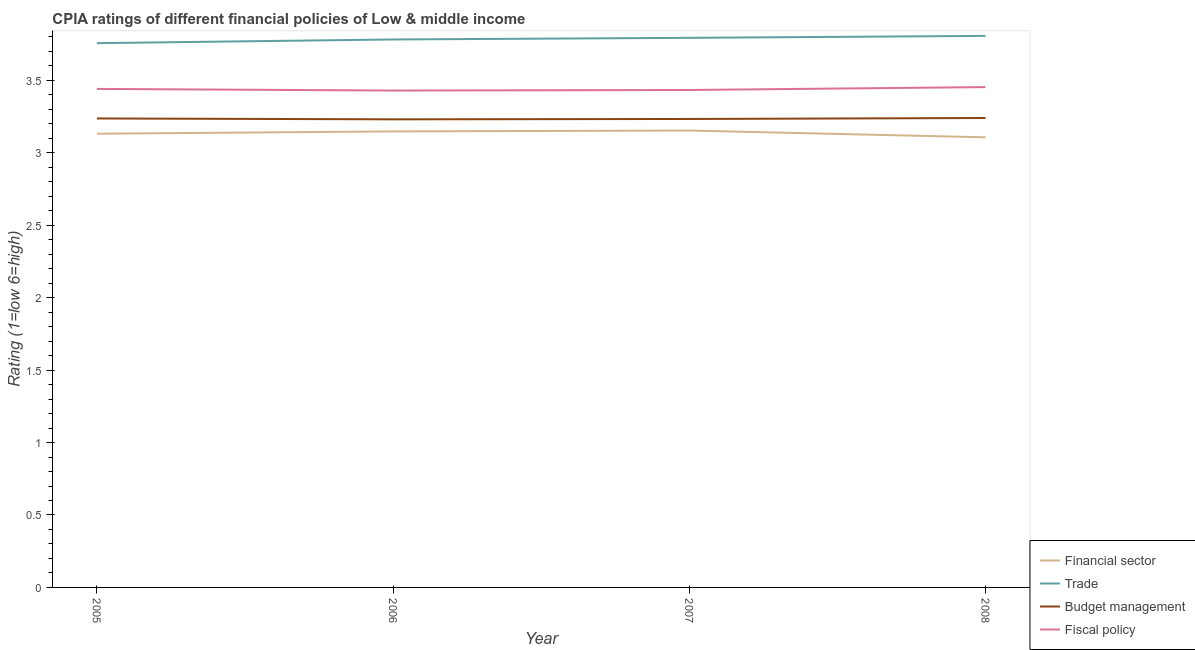How many different coloured lines are there?
Ensure brevity in your answer.  4. Does the line corresponding to cpia rating of financial sector intersect with the line corresponding to cpia rating of budget management?
Ensure brevity in your answer.  No. What is the cpia rating of financial sector in 2005?
Provide a succinct answer. 3.13. Across all years, what is the maximum cpia rating of fiscal policy?
Your answer should be compact. 3.45. Across all years, what is the minimum cpia rating of budget management?
Ensure brevity in your answer.  3.23. In which year was the cpia rating of trade maximum?
Your answer should be very brief. 2008. What is the total cpia rating of trade in the graph?
Keep it short and to the point. 15.14. What is the difference between the cpia rating of budget management in 2007 and that in 2008?
Your response must be concise. -0.01. What is the difference between the cpia rating of trade in 2007 and the cpia rating of financial sector in 2008?
Offer a terse response. 0.69. What is the average cpia rating of budget management per year?
Offer a very short reply. 3.24. In the year 2007, what is the difference between the cpia rating of fiscal policy and cpia rating of trade?
Offer a terse response. -0.36. What is the ratio of the cpia rating of fiscal policy in 2005 to that in 2006?
Provide a short and direct response. 1. What is the difference between the highest and the second highest cpia rating of budget management?
Keep it short and to the point. 0. What is the difference between the highest and the lowest cpia rating of budget management?
Provide a succinct answer. 0.01. How many lines are there?
Ensure brevity in your answer.  4. How many years are there in the graph?
Offer a terse response. 4. Does the graph contain any zero values?
Your response must be concise. No. Does the graph contain grids?
Your answer should be compact. No. How many legend labels are there?
Provide a short and direct response. 4. What is the title of the graph?
Offer a very short reply. CPIA ratings of different financial policies of Low & middle income. Does "Greece" appear as one of the legend labels in the graph?
Ensure brevity in your answer.  No. What is the label or title of the X-axis?
Keep it short and to the point. Year. What is the label or title of the Y-axis?
Offer a very short reply. Rating (1=low 6=high). What is the Rating (1=low 6=high) of Financial sector in 2005?
Ensure brevity in your answer.  3.13. What is the Rating (1=low 6=high) in Trade in 2005?
Offer a very short reply. 3.76. What is the Rating (1=low 6=high) in Budget management in 2005?
Your answer should be very brief. 3.24. What is the Rating (1=low 6=high) of Fiscal policy in 2005?
Offer a very short reply. 3.44. What is the Rating (1=low 6=high) of Financial sector in 2006?
Offer a very short reply. 3.15. What is the Rating (1=low 6=high) in Trade in 2006?
Your answer should be compact. 3.78. What is the Rating (1=low 6=high) in Budget management in 2006?
Provide a succinct answer. 3.23. What is the Rating (1=low 6=high) of Fiscal policy in 2006?
Ensure brevity in your answer.  3.43. What is the Rating (1=low 6=high) of Financial sector in 2007?
Your answer should be compact. 3.15. What is the Rating (1=low 6=high) in Trade in 2007?
Ensure brevity in your answer.  3.79. What is the Rating (1=low 6=high) in Budget management in 2007?
Ensure brevity in your answer.  3.23. What is the Rating (1=low 6=high) in Fiscal policy in 2007?
Your answer should be very brief. 3.43. What is the Rating (1=low 6=high) of Financial sector in 2008?
Give a very brief answer. 3.11. What is the Rating (1=low 6=high) in Trade in 2008?
Your answer should be compact. 3.81. What is the Rating (1=low 6=high) in Budget management in 2008?
Your response must be concise. 3.24. What is the Rating (1=low 6=high) of Fiscal policy in 2008?
Give a very brief answer. 3.45. Across all years, what is the maximum Rating (1=low 6=high) of Financial sector?
Offer a very short reply. 3.15. Across all years, what is the maximum Rating (1=low 6=high) of Trade?
Ensure brevity in your answer.  3.81. Across all years, what is the maximum Rating (1=low 6=high) in Budget management?
Your answer should be compact. 3.24. Across all years, what is the maximum Rating (1=low 6=high) in Fiscal policy?
Offer a very short reply. 3.45. Across all years, what is the minimum Rating (1=low 6=high) of Financial sector?
Provide a short and direct response. 3.11. Across all years, what is the minimum Rating (1=low 6=high) in Trade?
Your answer should be compact. 3.76. Across all years, what is the minimum Rating (1=low 6=high) in Budget management?
Provide a short and direct response. 3.23. Across all years, what is the minimum Rating (1=low 6=high) of Fiscal policy?
Keep it short and to the point. 3.43. What is the total Rating (1=low 6=high) of Financial sector in the graph?
Provide a short and direct response. 12.54. What is the total Rating (1=low 6=high) in Trade in the graph?
Ensure brevity in your answer.  15.14. What is the total Rating (1=low 6=high) in Budget management in the graph?
Ensure brevity in your answer.  12.94. What is the total Rating (1=low 6=high) of Fiscal policy in the graph?
Provide a succinct answer. 13.76. What is the difference between the Rating (1=low 6=high) in Financial sector in 2005 and that in 2006?
Your answer should be compact. -0.02. What is the difference between the Rating (1=low 6=high) of Trade in 2005 and that in 2006?
Make the answer very short. -0.03. What is the difference between the Rating (1=low 6=high) in Budget management in 2005 and that in 2006?
Your response must be concise. 0.01. What is the difference between the Rating (1=low 6=high) in Fiscal policy in 2005 and that in 2006?
Make the answer very short. 0.01. What is the difference between the Rating (1=low 6=high) in Financial sector in 2005 and that in 2007?
Your answer should be very brief. -0.02. What is the difference between the Rating (1=low 6=high) in Trade in 2005 and that in 2007?
Provide a short and direct response. -0.04. What is the difference between the Rating (1=low 6=high) in Budget management in 2005 and that in 2007?
Your answer should be very brief. 0. What is the difference between the Rating (1=low 6=high) of Fiscal policy in 2005 and that in 2007?
Provide a succinct answer. 0.01. What is the difference between the Rating (1=low 6=high) of Financial sector in 2005 and that in 2008?
Offer a terse response. 0.02. What is the difference between the Rating (1=low 6=high) of Trade in 2005 and that in 2008?
Provide a short and direct response. -0.05. What is the difference between the Rating (1=low 6=high) in Budget management in 2005 and that in 2008?
Your answer should be compact. -0. What is the difference between the Rating (1=low 6=high) in Fiscal policy in 2005 and that in 2008?
Your answer should be compact. -0.01. What is the difference between the Rating (1=low 6=high) in Financial sector in 2006 and that in 2007?
Your response must be concise. -0.01. What is the difference between the Rating (1=low 6=high) in Trade in 2006 and that in 2007?
Give a very brief answer. -0.01. What is the difference between the Rating (1=low 6=high) in Budget management in 2006 and that in 2007?
Provide a succinct answer. -0. What is the difference between the Rating (1=low 6=high) in Fiscal policy in 2006 and that in 2007?
Offer a terse response. -0. What is the difference between the Rating (1=low 6=high) in Financial sector in 2006 and that in 2008?
Your answer should be very brief. 0.04. What is the difference between the Rating (1=low 6=high) of Trade in 2006 and that in 2008?
Offer a very short reply. -0.02. What is the difference between the Rating (1=low 6=high) of Budget management in 2006 and that in 2008?
Your response must be concise. -0.01. What is the difference between the Rating (1=low 6=high) of Fiscal policy in 2006 and that in 2008?
Your answer should be compact. -0.02. What is the difference between the Rating (1=low 6=high) of Financial sector in 2007 and that in 2008?
Ensure brevity in your answer.  0.05. What is the difference between the Rating (1=low 6=high) in Trade in 2007 and that in 2008?
Provide a succinct answer. -0.01. What is the difference between the Rating (1=low 6=high) in Budget management in 2007 and that in 2008?
Make the answer very short. -0.01. What is the difference between the Rating (1=low 6=high) in Fiscal policy in 2007 and that in 2008?
Your answer should be very brief. -0.02. What is the difference between the Rating (1=low 6=high) of Financial sector in 2005 and the Rating (1=low 6=high) of Trade in 2006?
Your answer should be compact. -0.65. What is the difference between the Rating (1=low 6=high) of Financial sector in 2005 and the Rating (1=low 6=high) of Budget management in 2006?
Provide a succinct answer. -0.1. What is the difference between the Rating (1=low 6=high) of Financial sector in 2005 and the Rating (1=low 6=high) of Fiscal policy in 2006?
Your response must be concise. -0.3. What is the difference between the Rating (1=low 6=high) of Trade in 2005 and the Rating (1=low 6=high) of Budget management in 2006?
Your answer should be compact. 0.53. What is the difference between the Rating (1=low 6=high) in Trade in 2005 and the Rating (1=low 6=high) in Fiscal policy in 2006?
Make the answer very short. 0.33. What is the difference between the Rating (1=low 6=high) in Budget management in 2005 and the Rating (1=low 6=high) in Fiscal policy in 2006?
Offer a very short reply. -0.19. What is the difference between the Rating (1=low 6=high) of Financial sector in 2005 and the Rating (1=low 6=high) of Trade in 2007?
Offer a very short reply. -0.66. What is the difference between the Rating (1=low 6=high) of Financial sector in 2005 and the Rating (1=low 6=high) of Budget management in 2007?
Your answer should be very brief. -0.1. What is the difference between the Rating (1=low 6=high) in Financial sector in 2005 and the Rating (1=low 6=high) in Fiscal policy in 2007?
Your response must be concise. -0.3. What is the difference between the Rating (1=low 6=high) of Trade in 2005 and the Rating (1=low 6=high) of Budget management in 2007?
Offer a terse response. 0.52. What is the difference between the Rating (1=low 6=high) of Trade in 2005 and the Rating (1=low 6=high) of Fiscal policy in 2007?
Your response must be concise. 0.32. What is the difference between the Rating (1=low 6=high) of Budget management in 2005 and the Rating (1=low 6=high) of Fiscal policy in 2007?
Give a very brief answer. -0.2. What is the difference between the Rating (1=low 6=high) of Financial sector in 2005 and the Rating (1=low 6=high) of Trade in 2008?
Provide a short and direct response. -0.68. What is the difference between the Rating (1=low 6=high) in Financial sector in 2005 and the Rating (1=low 6=high) in Budget management in 2008?
Offer a very short reply. -0.11. What is the difference between the Rating (1=low 6=high) in Financial sector in 2005 and the Rating (1=low 6=high) in Fiscal policy in 2008?
Your answer should be compact. -0.32. What is the difference between the Rating (1=low 6=high) in Trade in 2005 and the Rating (1=low 6=high) in Budget management in 2008?
Offer a very short reply. 0.52. What is the difference between the Rating (1=low 6=high) of Trade in 2005 and the Rating (1=low 6=high) of Fiscal policy in 2008?
Provide a short and direct response. 0.3. What is the difference between the Rating (1=low 6=high) in Budget management in 2005 and the Rating (1=low 6=high) in Fiscal policy in 2008?
Your answer should be very brief. -0.22. What is the difference between the Rating (1=low 6=high) of Financial sector in 2006 and the Rating (1=low 6=high) of Trade in 2007?
Provide a short and direct response. -0.65. What is the difference between the Rating (1=low 6=high) of Financial sector in 2006 and the Rating (1=low 6=high) of Budget management in 2007?
Make the answer very short. -0.09. What is the difference between the Rating (1=low 6=high) of Financial sector in 2006 and the Rating (1=low 6=high) of Fiscal policy in 2007?
Offer a terse response. -0.29. What is the difference between the Rating (1=low 6=high) in Trade in 2006 and the Rating (1=low 6=high) in Budget management in 2007?
Offer a very short reply. 0.55. What is the difference between the Rating (1=low 6=high) of Trade in 2006 and the Rating (1=low 6=high) of Fiscal policy in 2007?
Offer a terse response. 0.35. What is the difference between the Rating (1=low 6=high) in Budget management in 2006 and the Rating (1=low 6=high) in Fiscal policy in 2007?
Your answer should be compact. -0.2. What is the difference between the Rating (1=low 6=high) in Financial sector in 2006 and the Rating (1=low 6=high) in Trade in 2008?
Provide a short and direct response. -0.66. What is the difference between the Rating (1=low 6=high) of Financial sector in 2006 and the Rating (1=low 6=high) of Budget management in 2008?
Offer a very short reply. -0.09. What is the difference between the Rating (1=low 6=high) of Financial sector in 2006 and the Rating (1=low 6=high) of Fiscal policy in 2008?
Ensure brevity in your answer.  -0.31. What is the difference between the Rating (1=low 6=high) of Trade in 2006 and the Rating (1=low 6=high) of Budget management in 2008?
Your answer should be very brief. 0.54. What is the difference between the Rating (1=low 6=high) in Trade in 2006 and the Rating (1=low 6=high) in Fiscal policy in 2008?
Your answer should be very brief. 0.33. What is the difference between the Rating (1=low 6=high) of Budget management in 2006 and the Rating (1=low 6=high) of Fiscal policy in 2008?
Your answer should be compact. -0.22. What is the difference between the Rating (1=low 6=high) in Financial sector in 2007 and the Rating (1=low 6=high) in Trade in 2008?
Offer a very short reply. -0.65. What is the difference between the Rating (1=low 6=high) of Financial sector in 2007 and the Rating (1=low 6=high) of Budget management in 2008?
Your answer should be compact. -0.09. What is the difference between the Rating (1=low 6=high) of Financial sector in 2007 and the Rating (1=low 6=high) of Fiscal policy in 2008?
Provide a succinct answer. -0.3. What is the difference between the Rating (1=low 6=high) of Trade in 2007 and the Rating (1=low 6=high) of Budget management in 2008?
Ensure brevity in your answer.  0.55. What is the difference between the Rating (1=low 6=high) in Trade in 2007 and the Rating (1=low 6=high) in Fiscal policy in 2008?
Offer a terse response. 0.34. What is the difference between the Rating (1=low 6=high) in Budget management in 2007 and the Rating (1=low 6=high) in Fiscal policy in 2008?
Provide a short and direct response. -0.22. What is the average Rating (1=low 6=high) of Financial sector per year?
Offer a terse response. 3.13. What is the average Rating (1=low 6=high) of Trade per year?
Your answer should be very brief. 3.78. What is the average Rating (1=low 6=high) in Budget management per year?
Make the answer very short. 3.24. What is the average Rating (1=low 6=high) of Fiscal policy per year?
Offer a terse response. 3.44. In the year 2005, what is the difference between the Rating (1=low 6=high) of Financial sector and Rating (1=low 6=high) of Trade?
Give a very brief answer. -0.62. In the year 2005, what is the difference between the Rating (1=low 6=high) of Financial sector and Rating (1=low 6=high) of Budget management?
Provide a succinct answer. -0.11. In the year 2005, what is the difference between the Rating (1=low 6=high) in Financial sector and Rating (1=low 6=high) in Fiscal policy?
Ensure brevity in your answer.  -0.31. In the year 2005, what is the difference between the Rating (1=low 6=high) of Trade and Rating (1=low 6=high) of Budget management?
Give a very brief answer. 0.52. In the year 2005, what is the difference between the Rating (1=low 6=high) of Trade and Rating (1=low 6=high) of Fiscal policy?
Offer a very short reply. 0.32. In the year 2005, what is the difference between the Rating (1=low 6=high) in Budget management and Rating (1=low 6=high) in Fiscal policy?
Offer a very short reply. -0.2. In the year 2006, what is the difference between the Rating (1=low 6=high) in Financial sector and Rating (1=low 6=high) in Trade?
Provide a short and direct response. -0.63. In the year 2006, what is the difference between the Rating (1=low 6=high) in Financial sector and Rating (1=low 6=high) in Budget management?
Keep it short and to the point. -0.08. In the year 2006, what is the difference between the Rating (1=low 6=high) in Financial sector and Rating (1=low 6=high) in Fiscal policy?
Offer a terse response. -0.28. In the year 2006, what is the difference between the Rating (1=low 6=high) in Trade and Rating (1=low 6=high) in Budget management?
Give a very brief answer. 0.55. In the year 2006, what is the difference between the Rating (1=low 6=high) of Trade and Rating (1=low 6=high) of Fiscal policy?
Your answer should be very brief. 0.35. In the year 2006, what is the difference between the Rating (1=low 6=high) of Budget management and Rating (1=low 6=high) of Fiscal policy?
Your answer should be compact. -0.2. In the year 2007, what is the difference between the Rating (1=low 6=high) of Financial sector and Rating (1=low 6=high) of Trade?
Keep it short and to the point. -0.64. In the year 2007, what is the difference between the Rating (1=low 6=high) in Financial sector and Rating (1=low 6=high) in Budget management?
Your answer should be compact. -0.08. In the year 2007, what is the difference between the Rating (1=low 6=high) of Financial sector and Rating (1=low 6=high) of Fiscal policy?
Keep it short and to the point. -0.28. In the year 2007, what is the difference between the Rating (1=low 6=high) of Trade and Rating (1=low 6=high) of Budget management?
Your answer should be compact. 0.56. In the year 2007, what is the difference between the Rating (1=low 6=high) of Trade and Rating (1=low 6=high) of Fiscal policy?
Provide a short and direct response. 0.36. In the year 2007, what is the difference between the Rating (1=low 6=high) in Budget management and Rating (1=low 6=high) in Fiscal policy?
Your response must be concise. -0.2. In the year 2008, what is the difference between the Rating (1=low 6=high) of Financial sector and Rating (1=low 6=high) of Trade?
Provide a short and direct response. -0.7. In the year 2008, what is the difference between the Rating (1=low 6=high) of Financial sector and Rating (1=low 6=high) of Budget management?
Make the answer very short. -0.13. In the year 2008, what is the difference between the Rating (1=low 6=high) in Financial sector and Rating (1=low 6=high) in Fiscal policy?
Give a very brief answer. -0.35. In the year 2008, what is the difference between the Rating (1=low 6=high) in Trade and Rating (1=low 6=high) in Budget management?
Your answer should be very brief. 0.57. In the year 2008, what is the difference between the Rating (1=low 6=high) in Trade and Rating (1=low 6=high) in Fiscal policy?
Keep it short and to the point. 0.35. In the year 2008, what is the difference between the Rating (1=low 6=high) in Budget management and Rating (1=low 6=high) in Fiscal policy?
Your response must be concise. -0.21. What is the ratio of the Rating (1=low 6=high) in Financial sector in 2005 to that in 2006?
Your answer should be compact. 0.99. What is the ratio of the Rating (1=low 6=high) of Financial sector in 2005 to that in 2007?
Offer a terse response. 0.99. What is the ratio of the Rating (1=low 6=high) in Trade in 2005 to that in 2007?
Your answer should be compact. 0.99. What is the ratio of the Rating (1=low 6=high) of Financial sector in 2005 to that in 2008?
Give a very brief answer. 1.01. What is the ratio of the Rating (1=low 6=high) of Fiscal policy in 2005 to that in 2008?
Provide a short and direct response. 1. What is the ratio of the Rating (1=low 6=high) in Trade in 2006 to that in 2007?
Provide a succinct answer. 1. What is the ratio of the Rating (1=low 6=high) of Financial sector in 2006 to that in 2008?
Your answer should be very brief. 1.01. What is the ratio of the Rating (1=low 6=high) in Trade in 2006 to that in 2008?
Your answer should be compact. 0.99. What is the ratio of the Rating (1=low 6=high) in Budget management in 2006 to that in 2008?
Keep it short and to the point. 1. What is the ratio of the Rating (1=low 6=high) in Trade in 2007 to that in 2008?
Ensure brevity in your answer.  1. What is the difference between the highest and the second highest Rating (1=low 6=high) in Financial sector?
Your response must be concise. 0.01. What is the difference between the highest and the second highest Rating (1=low 6=high) in Trade?
Provide a short and direct response. 0.01. What is the difference between the highest and the second highest Rating (1=low 6=high) of Budget management?
Your response must be concise. 0. What is the difference between the highest and the second highest Rating (1=low 6=high) in Fiscal policy?
Provide a succinct answer. 0.01. What is the difference between the highest and the lowest Rating (1=low 6=high) of Financial sector?
Provide a short and direct response. 0.05. What is the difference between the highest and the lowest Rating (1=low 6=high) of Trade?
Your response must be concise. 0.05. What is the difference between the highest and the lowest Rating (1=low 6=high) in Budget management?
Your answer should be compact. 0.01. What is the difference between the highest and the lowest Rating (1=low 6=high) of Fiscal policy?
Make the answer very short. 0.02. 